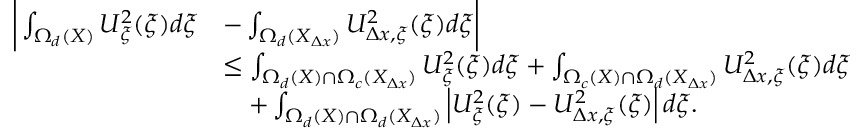Convert formula to latex. <formula><loc_0><loc_0><loc_500><loc_500>\begin{array} { r l } { \left | \int _ { \Omega _ { d } ( X ) } U _ { \xi } ^ { 2 } ( \xi ) d \xi } & { - \int _ { \Omega _ { d } ( X _ { \Delta x } ) } U _ { \Delta x , \xi } ^ { 2 } ( \xi ) d \xi \right | } \\ & { \leq \int _ { \Omega _ { d } ( X ) \cap \Omega _ { c } ( X _ { \Delta x } ) } U _ { \xi } ^ { 2 } ( \xi ) d \xi + \int _ { \Omega _ { c } ( X ) \cap \Omega _ { d } ( X _ { \Delta x } ) } U _ { \Delta x , \xi } ^ { 2 } ( \xi ) d \xi } \\ & { \quad + \int _ { \Omega _ { d } ( X ) \cap \Omega _ { d } ( X _ { \Delta x } ) } \left | U _ { \xi } ^ { 2 } ( \xi ) - U _ { \Delta x , \xi } ^ { 2 } ( \xi ) \right | d \xi . } \end{array}</formula> 